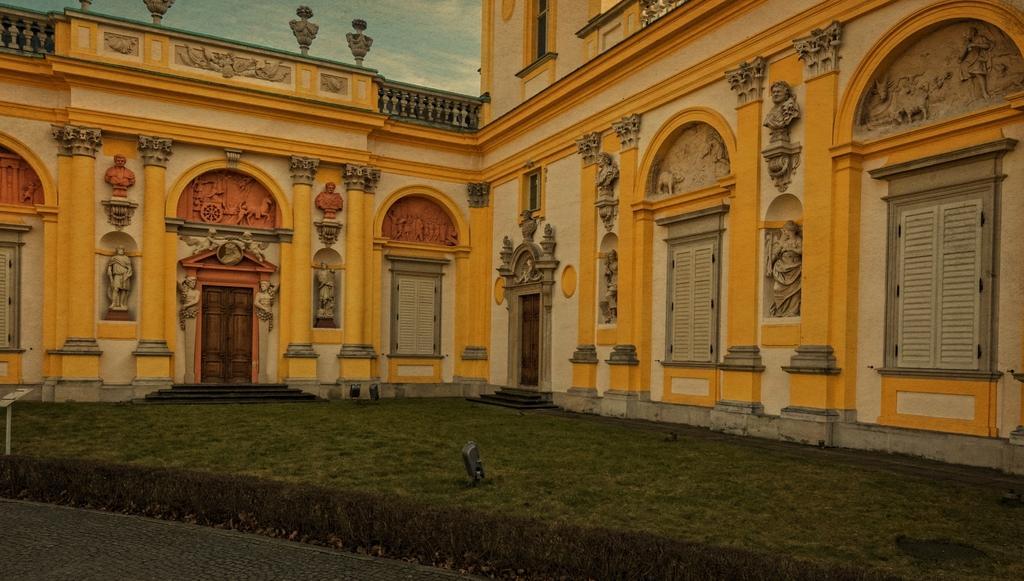Can you describe this image briefly? In the image we can see the building, sculptures and the sky. Here we can see stairs, door, glass and window blinds. 